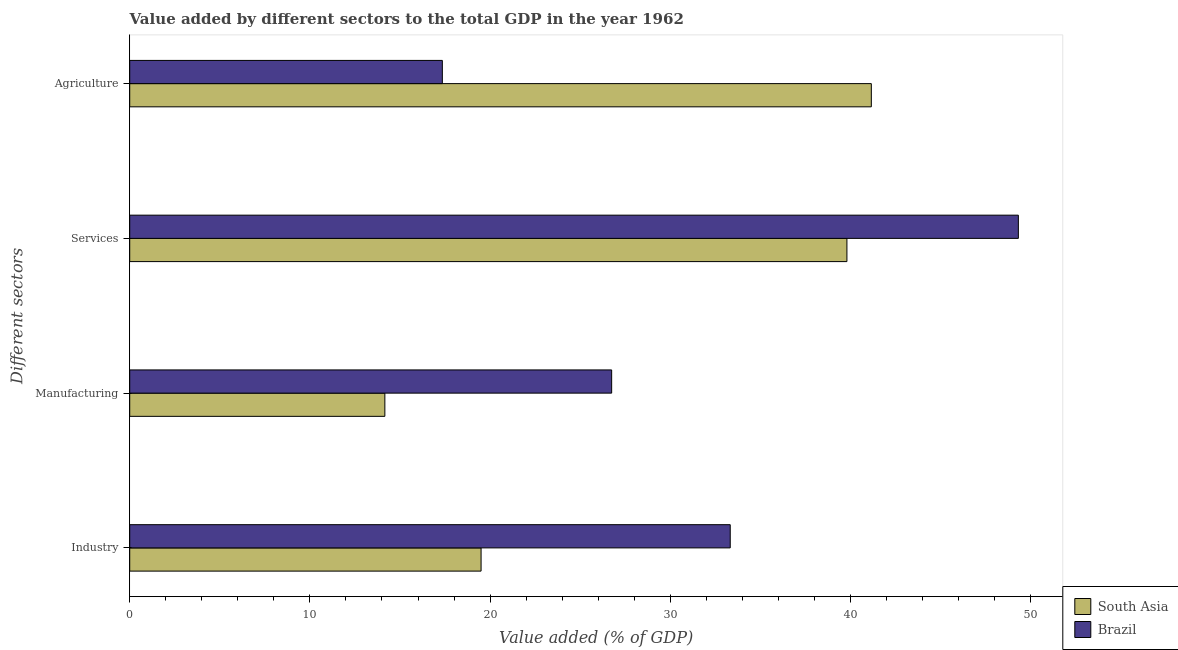How many groups of bars are there?
Give a very brief answer. 4. Are the number of bars per tick equal to the number of legend labels?
Make the answer very short. Yes. Are the number of bars on each tick of the Y-axis equal?
Keep it short and to the point. Yes. How many bars are there on the 2nd tick from the top?
Provide a succinct answer. 2. How many bars are there on the 1st tick from the bottom?
Offer a very short reply. 2. What is the label of the 2nd group of bars from the top?
Your response must be concise. Services. What is the value added by agricultural sector in Brazil?
Make the answer very short. 17.35. Across all countries, what is the maximum value added by services sector?
Keep it short and to the point. 49.32. Across all countries, what is the minimum value added by manufacturing sector?
Offer a terse response. 14.16. In which country was the value added by services sector maximum?
Offer a terse response. Brazil. What is the total value added by services sector in the graph?
Your answer should be compact. 89.13. What is the difference between the value added by industrial sector in South Asia and that in Brazil?
Keep it short and to the point. -13.83. What is the difference between the value added by industrial sector in South Asia and the value added by agricultural sector in Brazil?
Your answer should be compact. 2.15. What is the average value added by industrial sector per country?
Offer a terse response. 26.41. What is the difference between the value added by agricultural sector and value added by services sector in South Asia?
Offer a very short reply. 1.35. In how many countries, is the value added by agricultural sector greater than 10 %?
Your answer should be compact. 2. What is the ratio of the value added by manufacturing sector in South Asia to that in Brazil?
Your answer should be compact. 0.53. Is the value added by industrial sector in Brazil less than that in South Asia?
Your answer should be compact. No. What is the difference between the highest and the second highest value added by manufacturing sector?
Give a very brief answer. 12.59. What is the difference between the highest and the lowest value added by manufacturing sector?
Keep it short and to the point. 12.59. In how many countries, is the value added by industrial sector greater than the average value added by industrial sector taken over all countries?
Provide a short and direct response. 1. Is the sum of the value added by agricultural sector in South Asia and Brazil greater than the maximum value added by industrial sector across all countries?
Your answer should be compact. Yes. What does the 2nd bar from the top in Manufacturing represents?
Make the answer very short. South Asia. What does the 2nd bar from the bottom in Manufacturing represents?
Provide a succinct answer. Brazil. Is it the case that in every country, the sum of the value added by industrial sector and value added by manufacturing sector is greater than the value added by services sector?
Make the answer very short. No. How many bars are there?
Your answer should be compact. 8. Are all the bars in the graph horizontal?
Your answer should be very brief. Yes. How many countries are there in the graph?
Provide a succinct answer. 2. Where does the legend appear in the graph?
Keep it short and to the point. Bottom right. What is the title of the graph?
Your response must be concise. Value added by different sectors to the total GDP in the year 1962. What is the label or title of the X-axis?
Your response must be concise. Value added (% of GDP). What is the label or title of the Y-axis?
Your response must be concise. Different sectors. What is the Value added (% of GDP) in South Asia in Industry?
Your response must be concise. 19.5. What is the Value added (% of GDP) of Brazil in Industry?
Provide a short and direct response. 33.33. What is the Value added (% of GDP) in South Asia in Manufacturing?
Offer a very short reply. 14.16. What is the Value added (% of GDP) of Brazil in Manufacturing?
Your response must be concise. 26.75. What is the Value added (% of GDP) of South Asia in Services?
Ensure brevity in your answer.  39.81. What is the Value added (% of GDP) in Brazil in Services?
Your response must be concise. 49.32. What is the Value added (% of GDP) in South Asia in Agriculture?
Your answer should be compact. 41.16. What is the Value added (% of GDP) in Brazil in Agriculture?
Give a very brief answer. 17.35. Across all Different sectors, what is the maximum Value added (% of GDP) in South Asia?
Make the answer very short. 41.16. Across all Different sectors, what is the maximum Value added (% of GDP) in Brazil?
Keep it short and to the point. 49.32. Across all Different sectors, what is the minimum Value added (% of GDP) of South Asia?
Your response must be concise. 14.16. Across all Different sectors, what is the minimum Value added (% of GDP) in Brazil?
Offer a very short reply. 17.35. What is the total Value added (% of GDP) of South Asia in the graph?
Your answer should be compact. 114.63. What is the total Value added (% of GDP) of Brazil in the graph?
Keep it short and to the point. 126.75. What is the difference between the Value added (% of GDP) in South Asia in Industry and that in Manufacturing?
Ensure brevity in your answer.  5.34. What is the difference between the Value added (% of GDP) in Brazil in Industry and that in Manufacturing?
Provide a succinct answer. 6.58. What is the difference between the Value added (% of GDP) in South Asia in Industry and that in Services?
Keep it short and to the point. -20.3. What is the difference between the Value added (% of GDP) of Brazil in Industry and that in Services?
Provide a short and direct response. -15.99. What is the difference between the Value added (% of GDP) of South Asia in Industry and that in Agriculture?
Your answer should be very brief. -21.66. What is the difference between the Value added (% of GDP) of Brazil in Industry and that in Agriculture?
Make the answer very short. 15.98. What is the difference between the Value added (% of GDP) in South Asia in Manufacturing and that in Services?
Your answer should be very brief. -25.65. What is the difference between the Value added (% of GDP) of Brazil in Manufacturing and that in Services?
Provide a short and direct response. -22.57. What is the difference between the Value added (% of GDP) in South Asia in Manufacturing and that in Agriculture?
Your answer should be very brief. -27. What is the difference between the Value added (% of GDP) of Brazil in Manufacturing and that in Agriculture?
Provide a succinct answer. 9.4. What is the difference between the Value added (% of GDP) of South Asia in Services and that in Agriculture?
Offer a terse response. -1.35. What is the difference between the Value added (% of GDP) of Brazil in Services and that in Agriculture?
Provide a short and direct response. 31.97. What is the difference between the Value added (% of GDP) in South Asia in Industry and the Value added (% of GDP) in Brazil in Manufacturing?
Make the answer very short. -7.25. What is the difference between the Value added (% of GDP) in South Asia in Industry and the Value added (% of GDP) in Brazil in Services?
Provide a succinct answer. -29.82. What is the difference between the Value added (% of GDP) in South Asia in Industry and the Value added (% of GDP) in Brazil in Agriculture?
Provide a short and direct response. 2.15. What is the difference between the Value added (% of GDP) of South Asia in Manufacturing and the Value added (% of GDP) of Brazil in Services?
Your answer should be very brief. -35.16. What is the difference between the Value added (% of GDP) in South Asia in Manufacturing and the Value added (% of GDP) in Brazil in Agriculture?
Ensure brevity in your answer.  -3.19. What is the difference between the Value added (% of GDP) of South Asia in Services and the Value added (% of GDP) of Brazil in Agriculture?
Provide a succinct answer. 22.45. What is the average Value added (% of GDP) of South Asia per Different sectors?
Offer a terse response. 28.66. What is the average Value added (% of GDP) of Brazil per Different sectors?
Your response must be concise. 31.69. What is the difference between the Value added (% of GDP) in South Asia and Value added (% of GDP) in Brazil in Industry?
Keep it short and to the point. -13.83. What is the difference between the Value added (% of GDP) in South Asia and Value added (% of GDP) in Brazil in Manufacturing?
Keep it short and to the point. -12.59. What is the difference between the Value added (% of GDP) in South Asia and Value added (% of GDP) in Brazil in Services?
Make the answer very short. -9.52. What is the difference between the Value added (% of GDP) of South Asia and Value added (% of GDP) of Brazil in Agriculture?
Your response must be concise. 23.81. What is the ratio of the Value added (% of GDP) in South Asia in Industry to that in Manufacturing?
Offer a terse response. 1.38. What is the ratio of the Value added (% of GDP) of Brazil in Industry to that in Manufacturing?
Offer a terse response. 1.25. What is the ratio of the Value added (% of GDP) in South Asia in Industry to that in Services?
Your answer should be compact. 0.49. What is the ratio of the Value added (% of GDP) in Brazil in Industry to that in Services?
Make the answer very short. 0.68. What is the ratio of the Value added (% of GDP) in South Asia in Industry to that in Agriculture?
Make the answer very short. 0.47. What is the ratio of the Value added (% of GDP) of Brazil in Industry to that in Agriculture?
Keep it short and to the point. 1.92. What is the ratio of the Value added (% of GDP) of South Asia in Manufacturing to that in Services?
Your answer should be very brief. 0.36. What is the ratio of the Value added (% of GDP) in Brazil in Manufacturing to that in Services?
Your response must be concise. 0.54. What is the ratio of the Value added (% of GDP) in South Asia in Manufacturing to that in Agriculture?
Provide a short and direct response. 0.34. What is the ratio of the Value added (% of GDP) in Brazil in Manufacturing to that in Agriculture?
Provide a short and direct response. 1.54. What is the ratio of the Value added (% of GDP) in South Asia in Services to that in Agriculture?
Give a very brief answer. 0.97. What is the ratio of the Value added (% of GDP) of Brazil in Services to that in Agriculture?
Ensure brevity in your answer.  2.84. What is the difference between the highest and the second highest Value added (% of GDP) of South Asia?
Your response must be concise. 1.35. What is the difference between the highest and the second highest Value added (% of GDP) of Brazil?
Keep it short and to the point. 15.99. What is the difference between the highest and the lowest Value added (% of GDP) of South Asia?
Ensure brevity in your answer.  27. What is the difference between the highest and the lowest Value added (% of GDP) in Brazil?
Your response must be concise. 31.97. 